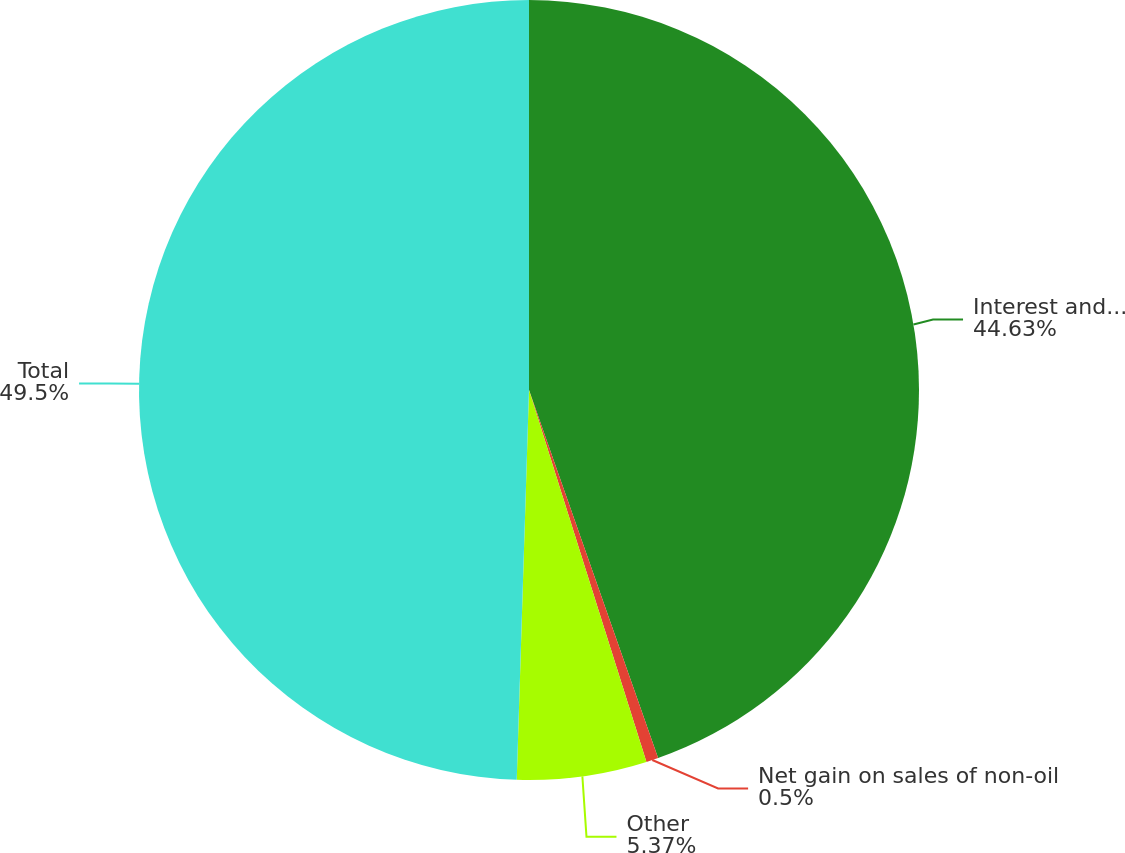<chart> <loc_0><loc_0><loc_500><loc_500><pie_chart><fcel>Interest and dividend income<fcel>Net gain on sales of non-oil<fcel>Other<fcel>Total<nl><fcel>44.63%<fcel>0.5%<fcel>5.37%<fcel>49.5%<nl></chart> 